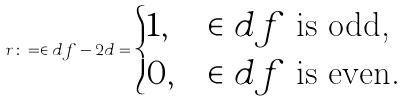Convert formula to latex. <formula><loc_0><loc_0><loc_500><loc_500>r \colon = \in d f - 2 d = \begin{cases} 1 , & \in d f \text { is odd,} \\ 0 , & \in d f \text { is even.} \end{cases}</formula> 